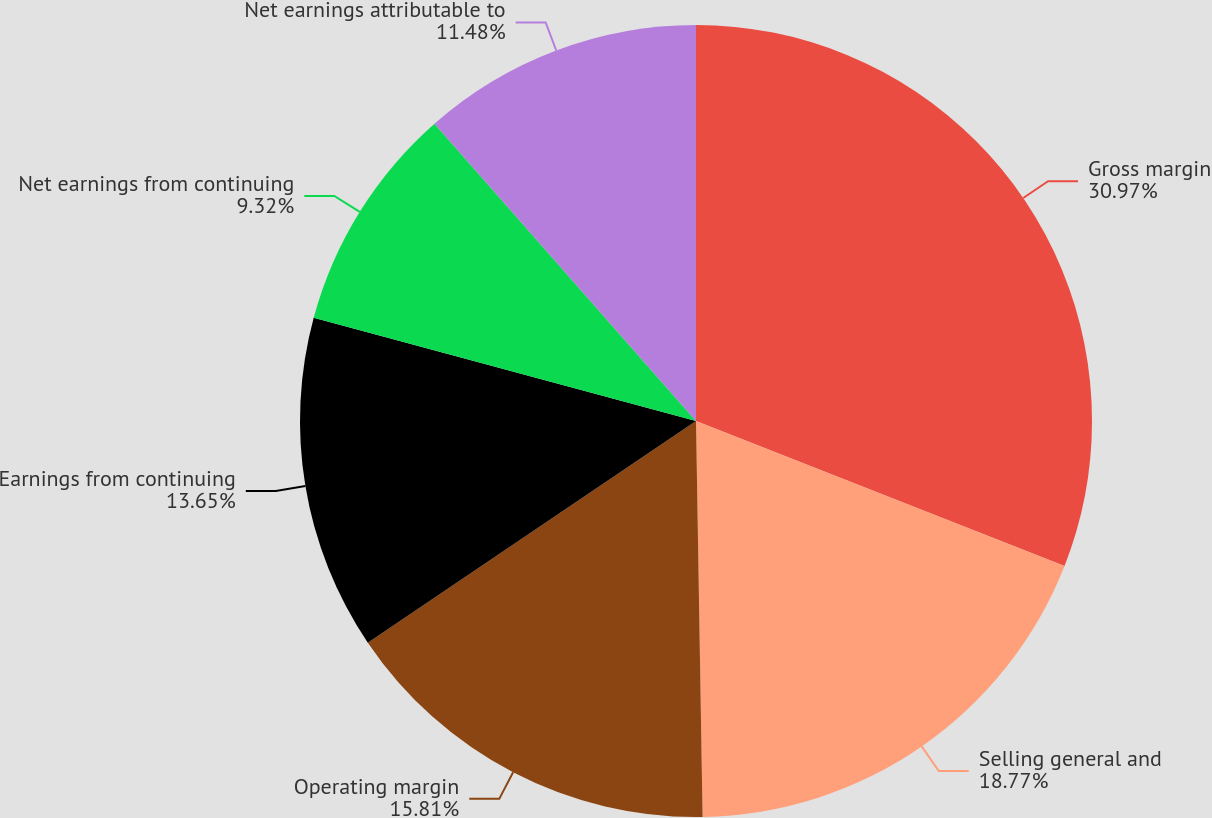Convert chart. <chart><loc_0><loc_0><loc_500><loc_500><pie_chart><fcel>Gross margin<fcel>Selling general and<fcel>Operating margin<fcel>Earnings from continuing<fcel>Net earnings from continuing<fcel>Net earnings attributable to<nl><fcel>30.96%<fcel>18.77%<fcel>15.81%<fcel>13.65%<fcel>9.32%<fcel>11.48%<nl></chart> 